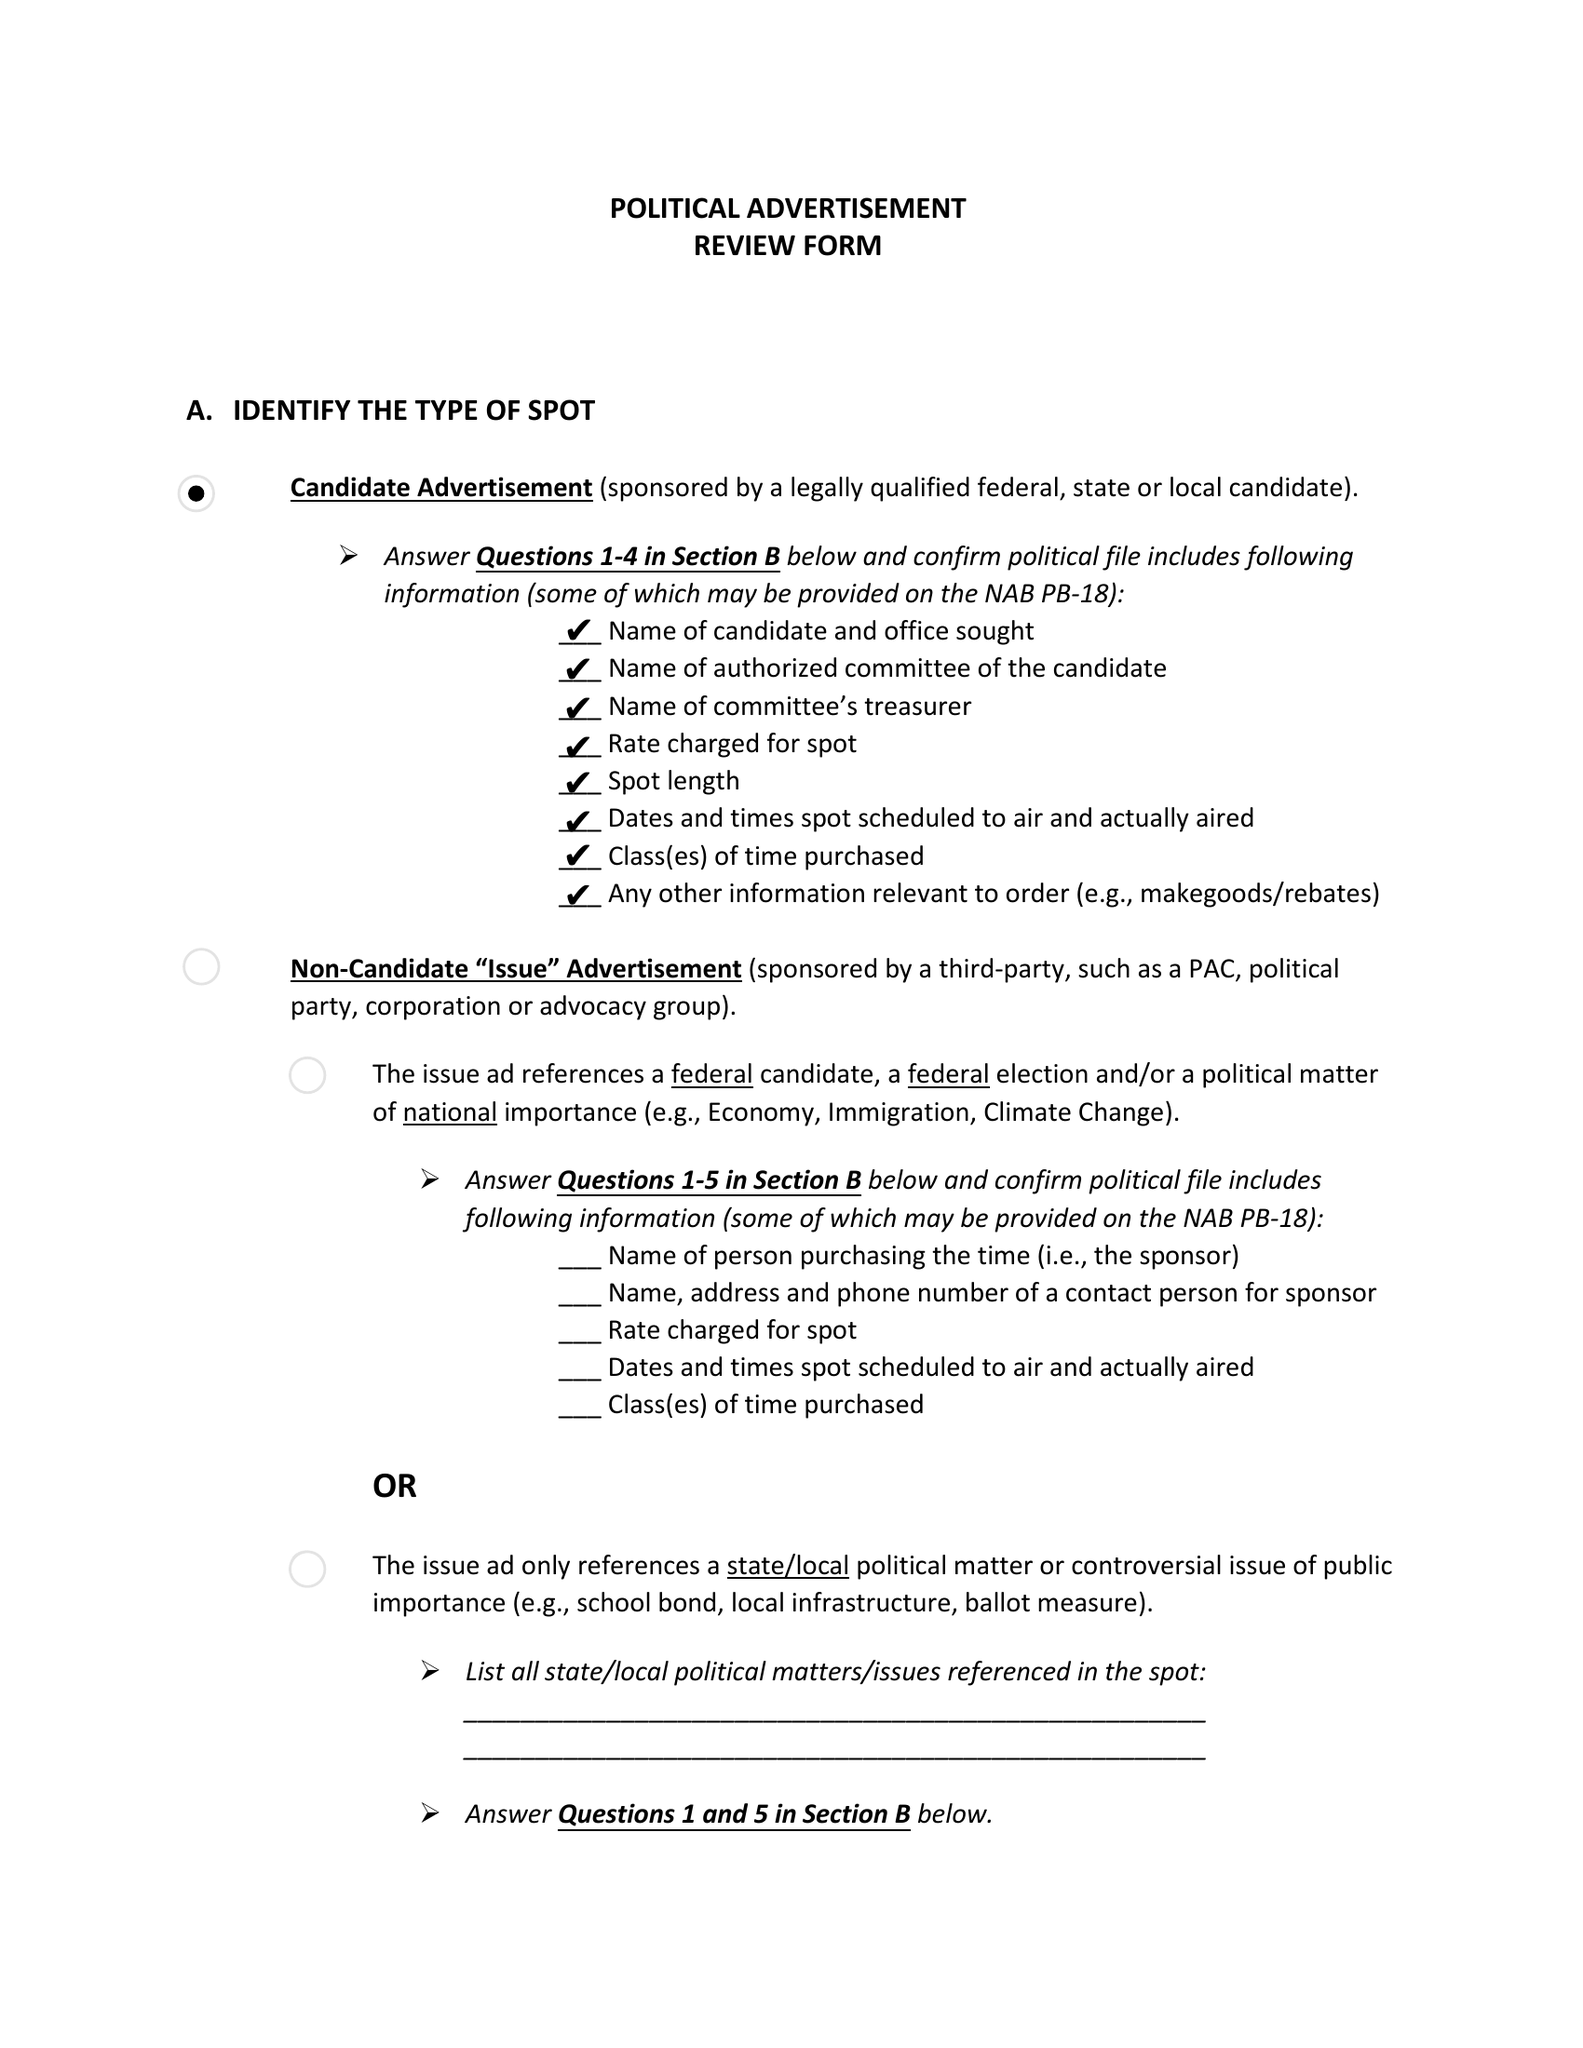What is the value for the gross_amount?
Answer the question using a single word or phrase. None 